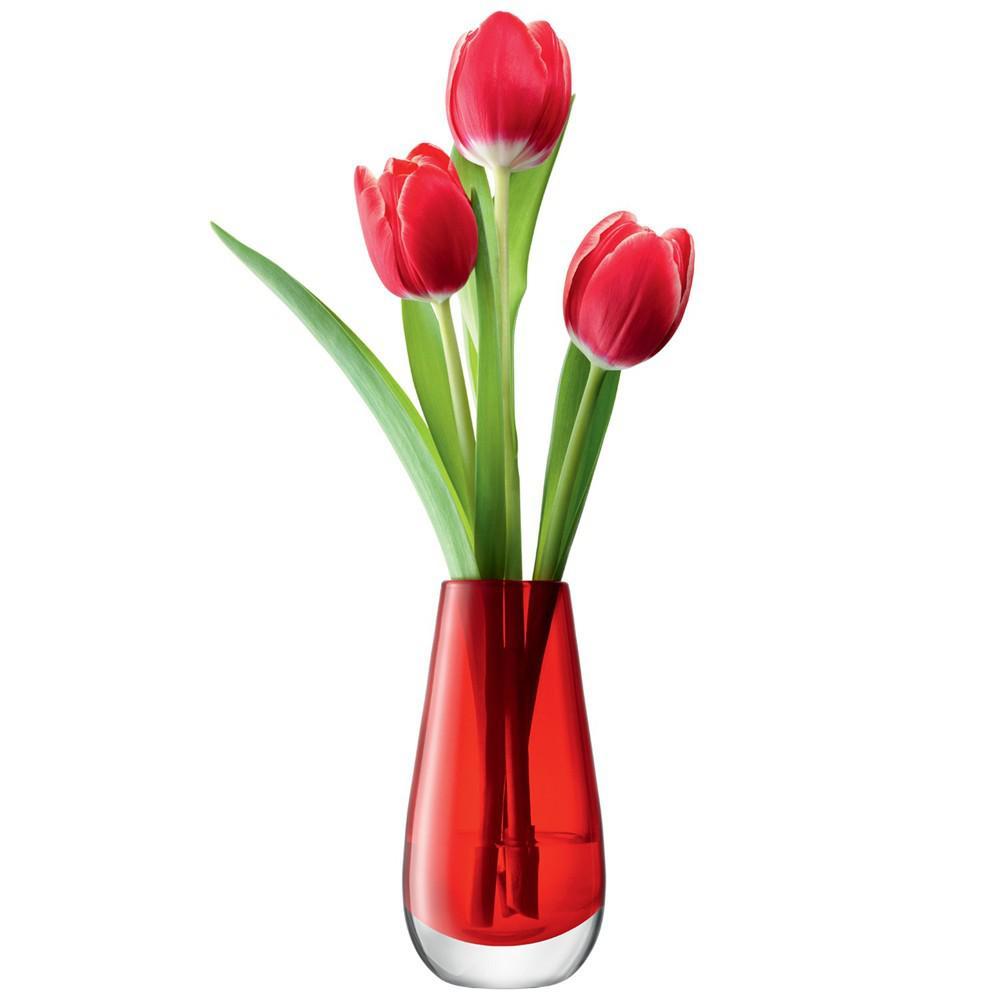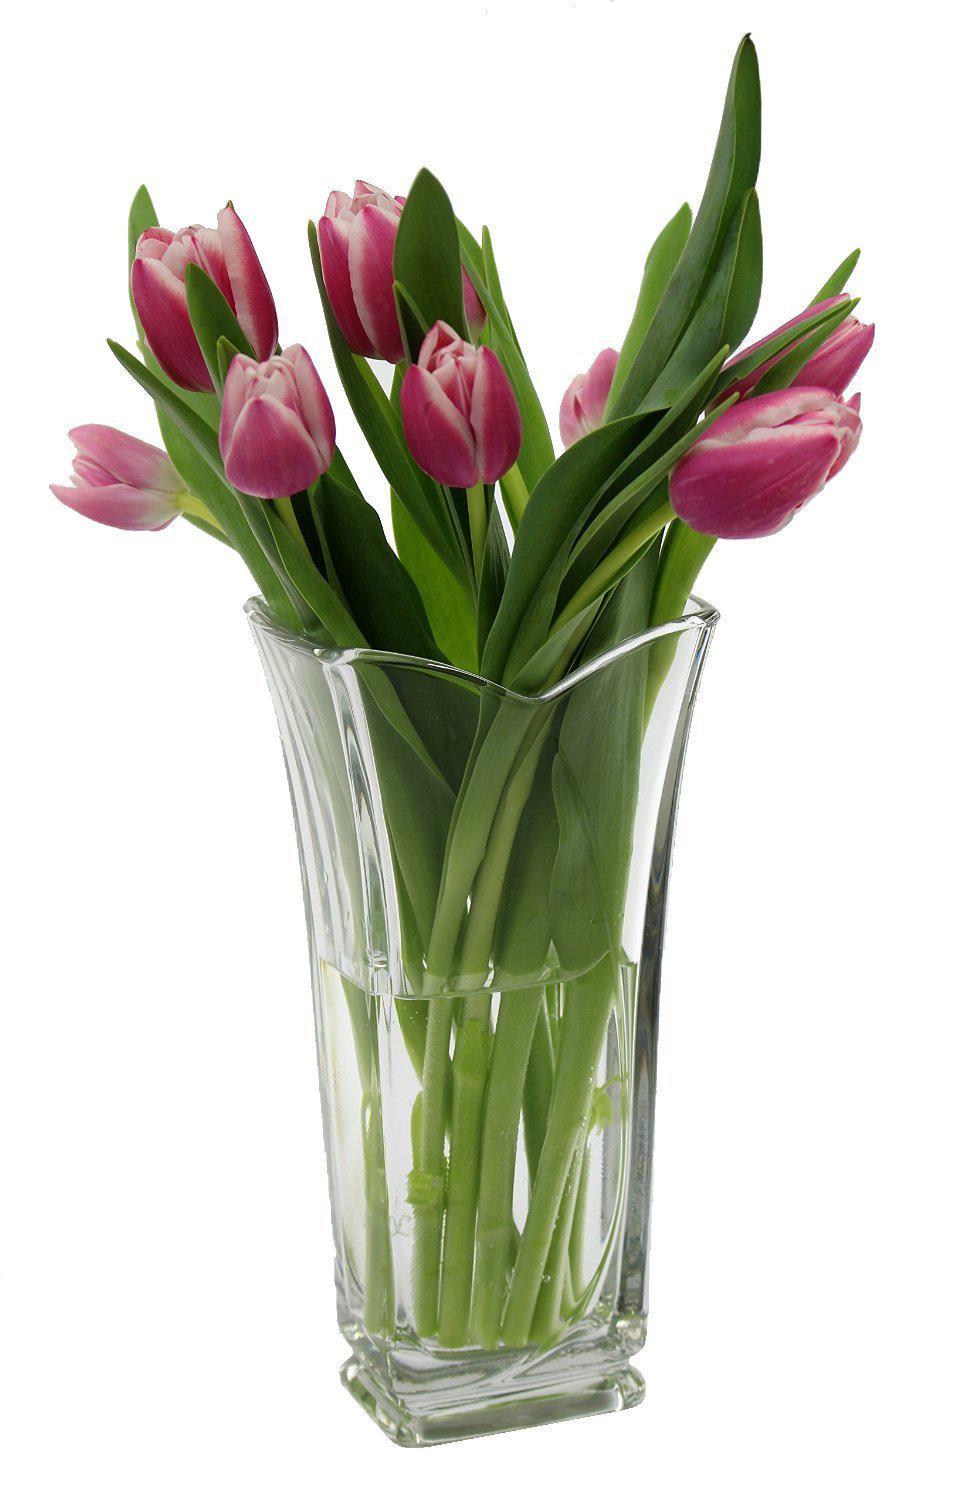The first image is the image on the left, the second image is the image on the right. For the images displayed, is the sentence "One of the images contains at least one vase that is completely opaque." factually correct? Answer yes or no. No. 